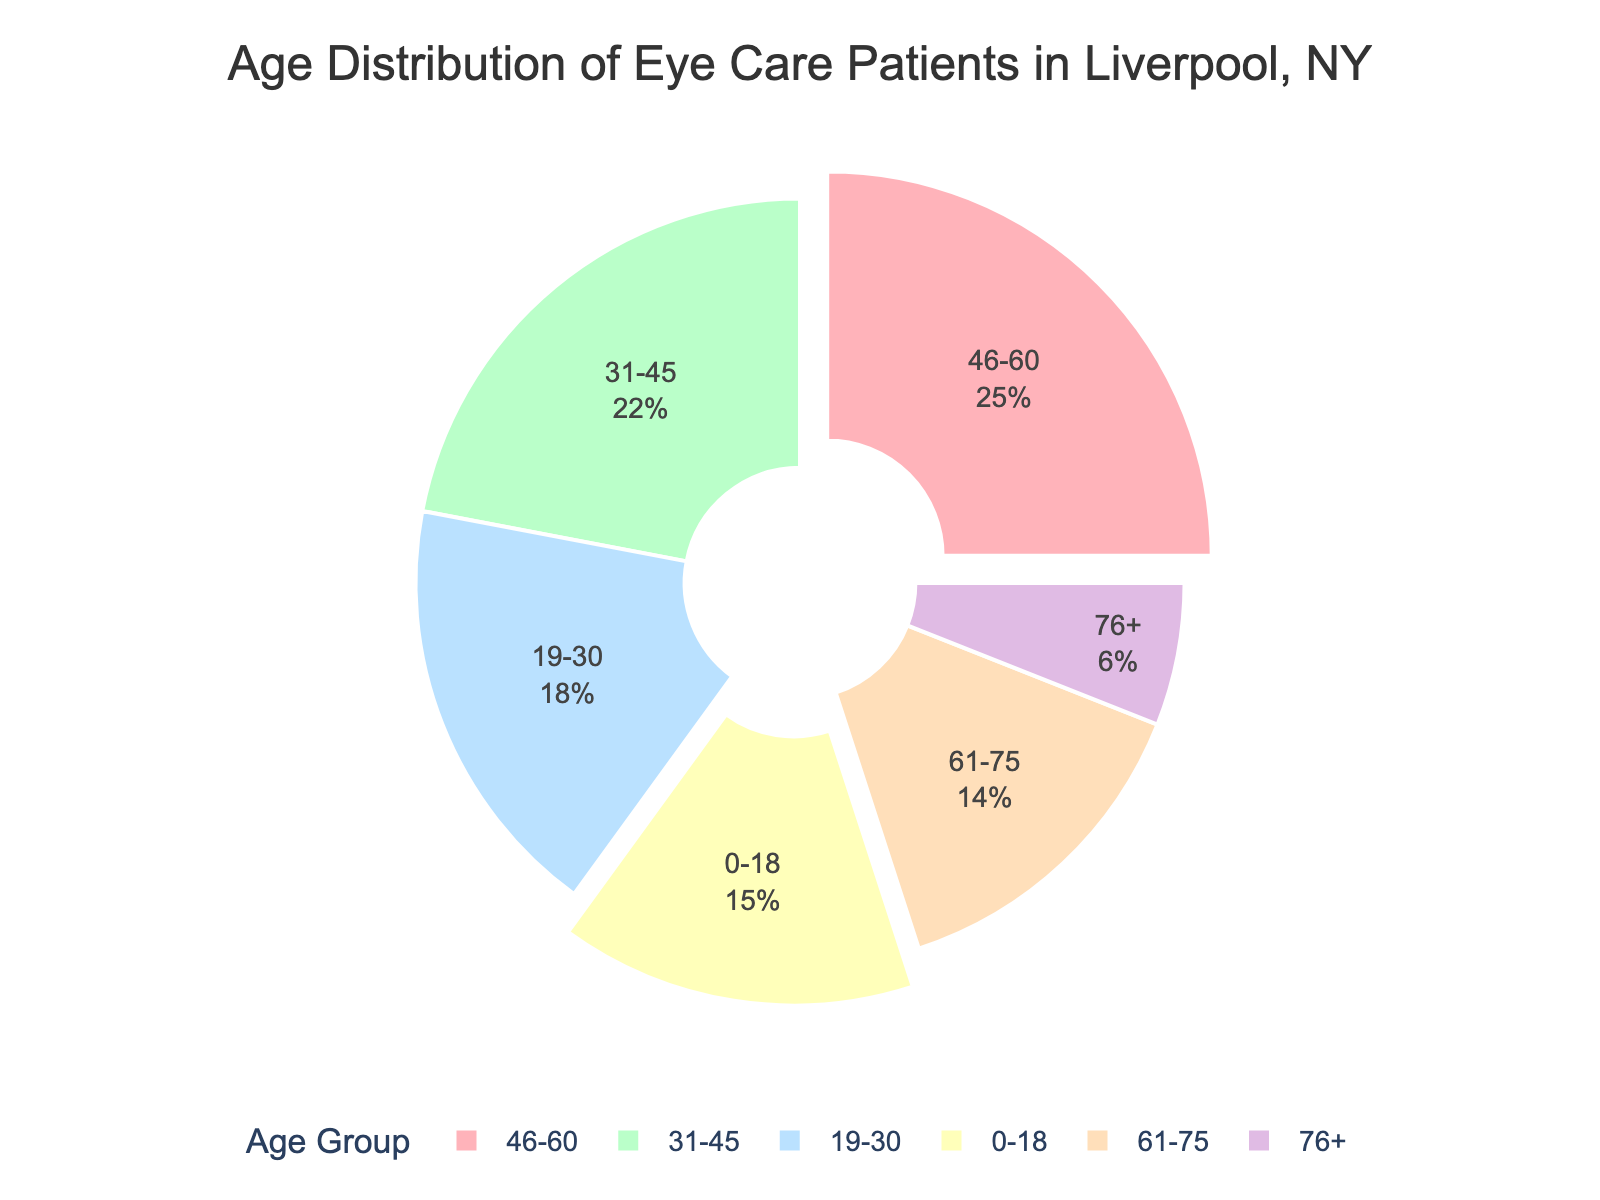what's the combined percentage of patients under 19 years old and over 75 years old? The percentage for the 0-18 age group is 15%, and for the 76+ age group is 6%. Summing these, 15% + 6% = 21%.
Answer: 21% which age group has the highest percentage of patients? By scanning the pie chart, the 46-60 age group is the largest segment with 25%.
Answer: 46-60 how much greater is the percentage of patients in the 31-45 age group compared to the 61-75 age group? The 31-45 age group has 22% and the 61-75 age group has 14%. Subtracting these, 22% - 14% = 8%.
Answer: 8% which two age groups have segments that are pulled out from the rest of the pie chart? By looking at the segments that are slightly separated from the rest, the 0-18 and 46-60 age groups are highlighted.
Answer: 0-18 and 46-60 are there more patients in the 19-30 age group or the 61-75 age group? The 19-30 age group shows 18%, while the 61-75 age group shows 14%. Therefore, there are more patients in the 19-30 age group.
Answer: 19-30 what is the approximate percentage of patients aged between 19 and 45? Combining the 19-30 age group (18%) and the 31-45 age group (22%), gives us approximately 18% + 22% = 40%.
Answer: 40% what color represents the age group with the smallest percentage? The 76+ age group segment in the pie chart is represented in purple.
Answer: purple which age group is represented by the yellow segment? By inspecting the chart, the yellow segment corresponds to the 61-75 age group.
Answer: 61-75 how does the percentage of patients in the 46-60 age group compare to the younger 0-18 age group and the older 61-75 age group together? The 46-60 group is 25%. The 0-18 group and the 61-75 group together are 15% + 14% = 29%. 25% is less than 29%.
Answer: less 